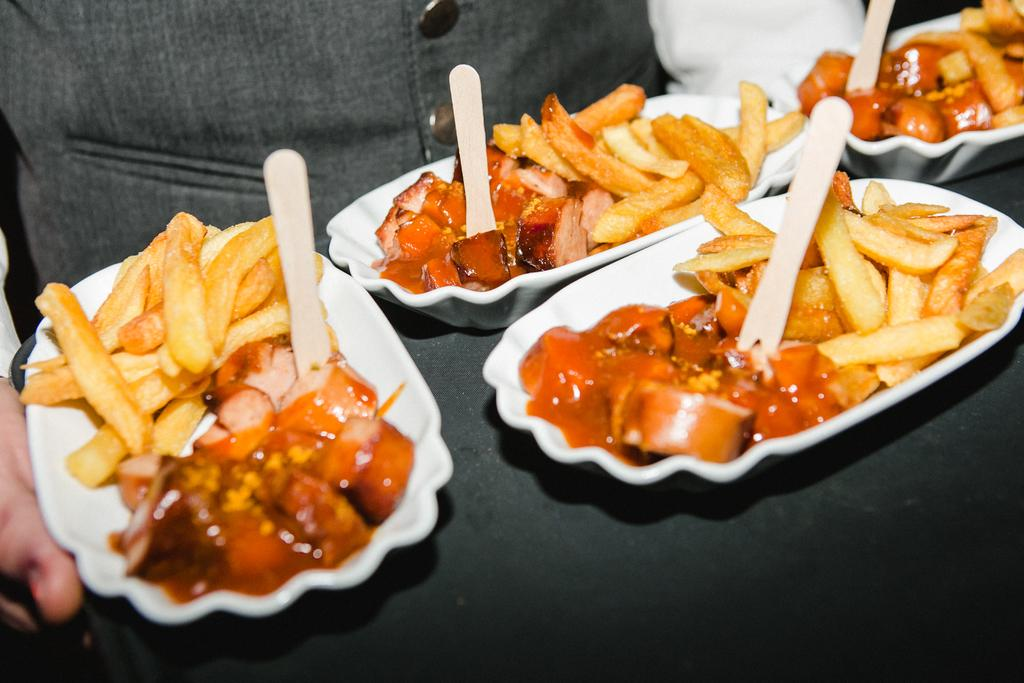What is the person in the image holding? The person is holding a serving tray in the image. What is on the serving tray? The serving tray contains serving plates. What is on the serving plates? The serving plates have food on them, and there are Popsicle sticks on the serving plates. What decision does the person holding the serving tray make in the image? There is no indication in the image that the person holding the serving tray is making a decision. 